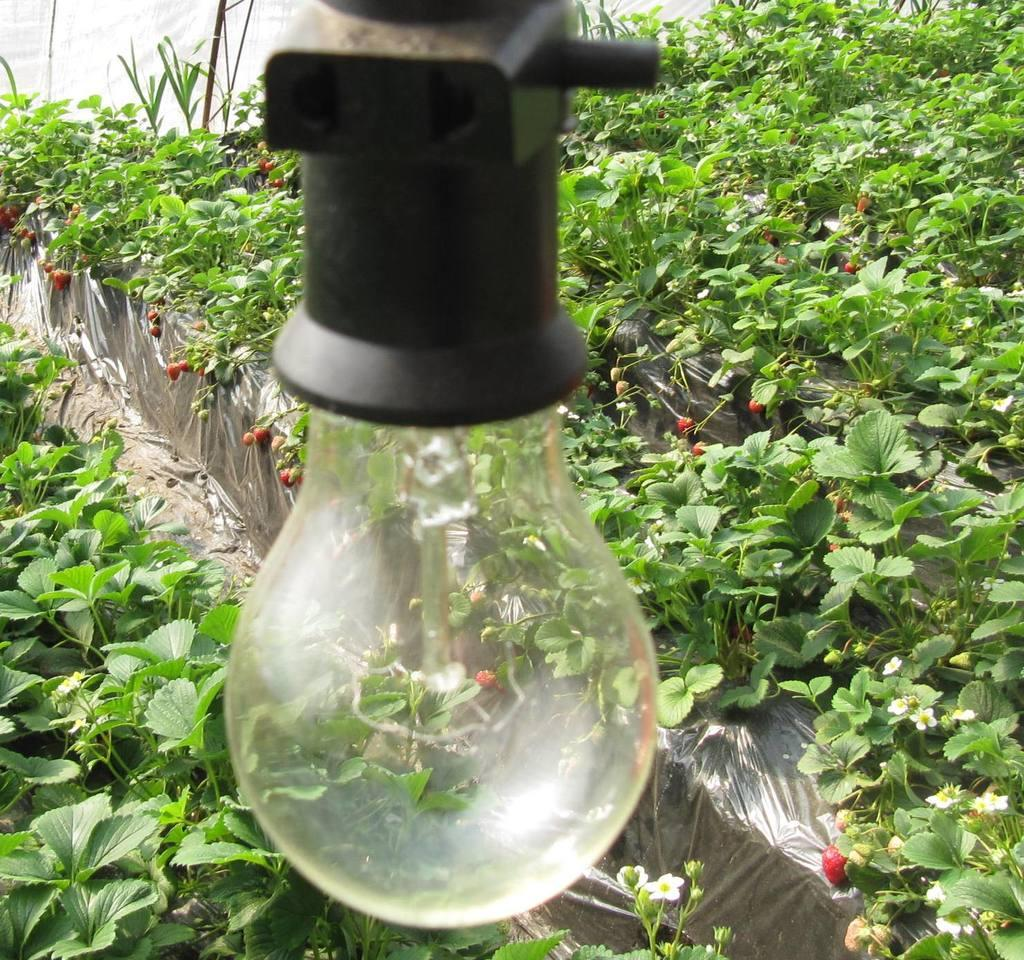What is the main object in the image? There is a bulb in the image. What type of vegetation is present in the image? There are green color leaves in the image. What can be seen in the background of the image? There are red color things in the background of the image. What type of toy is being used to enforce a rule in the image? There is no toy or rule enforcement present in the image. 